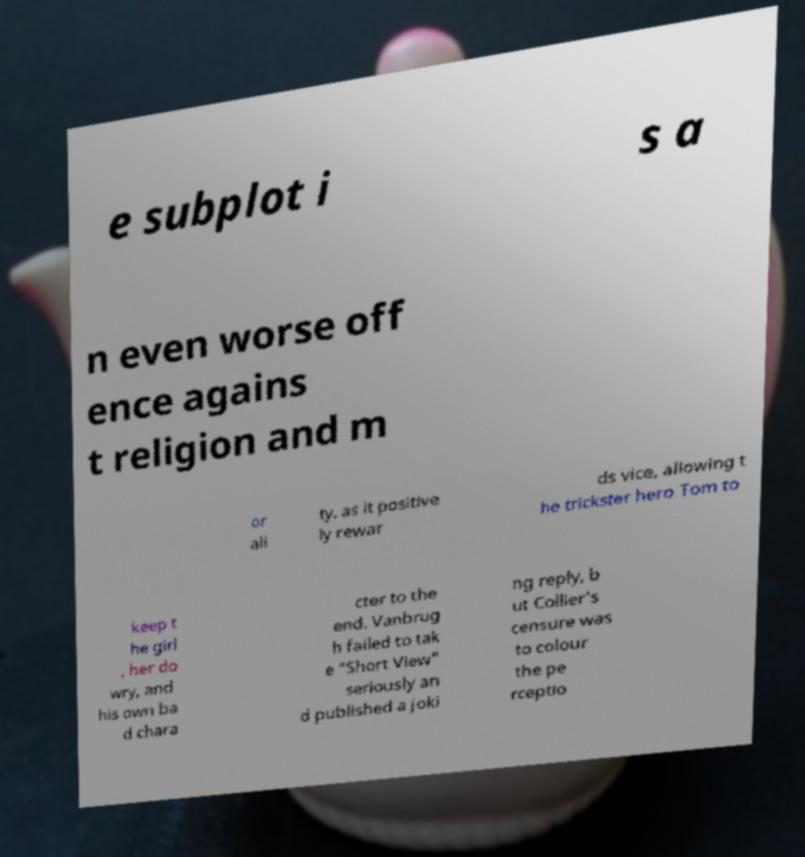I need the written content from this picture converted into text. Can you do that? e subplot i s a n even worse off ence agains t religion and m or ali ty, as it positive ly rewar ds vice, allowing t he trickster hero Tom to keep t he girl , her do wry, and his own ba d chara cter to the end. Vanbrug h failed to tak e "Short View" seriously an d published a joki ng reply, b ut Collier's censure was to colour the pe rceptio 